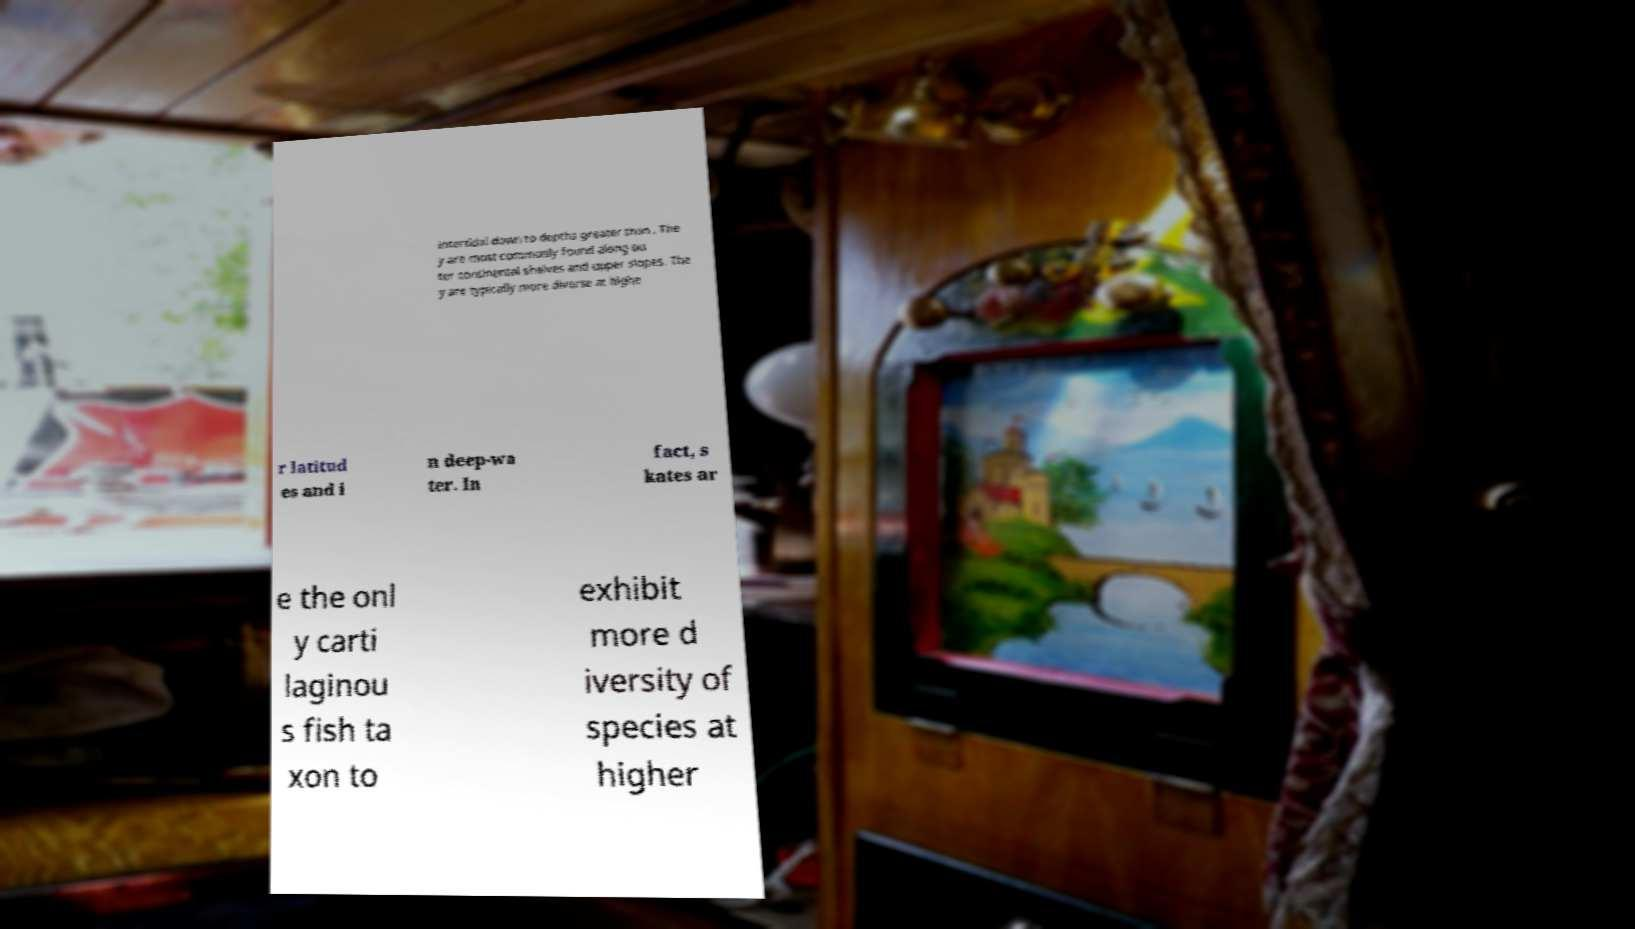Can you accurately transcribe the text from the provided image for me? intertidal down to depths greater than . The y are most commonly found along ou ter continental shelves and upper slopes. The y are typically more diverse at highe r latitud es and i n deep-wa ter. In fact, s kates ar e the onl y carti laginou s fish ta xon to exhibit more d iversity of species at higher 